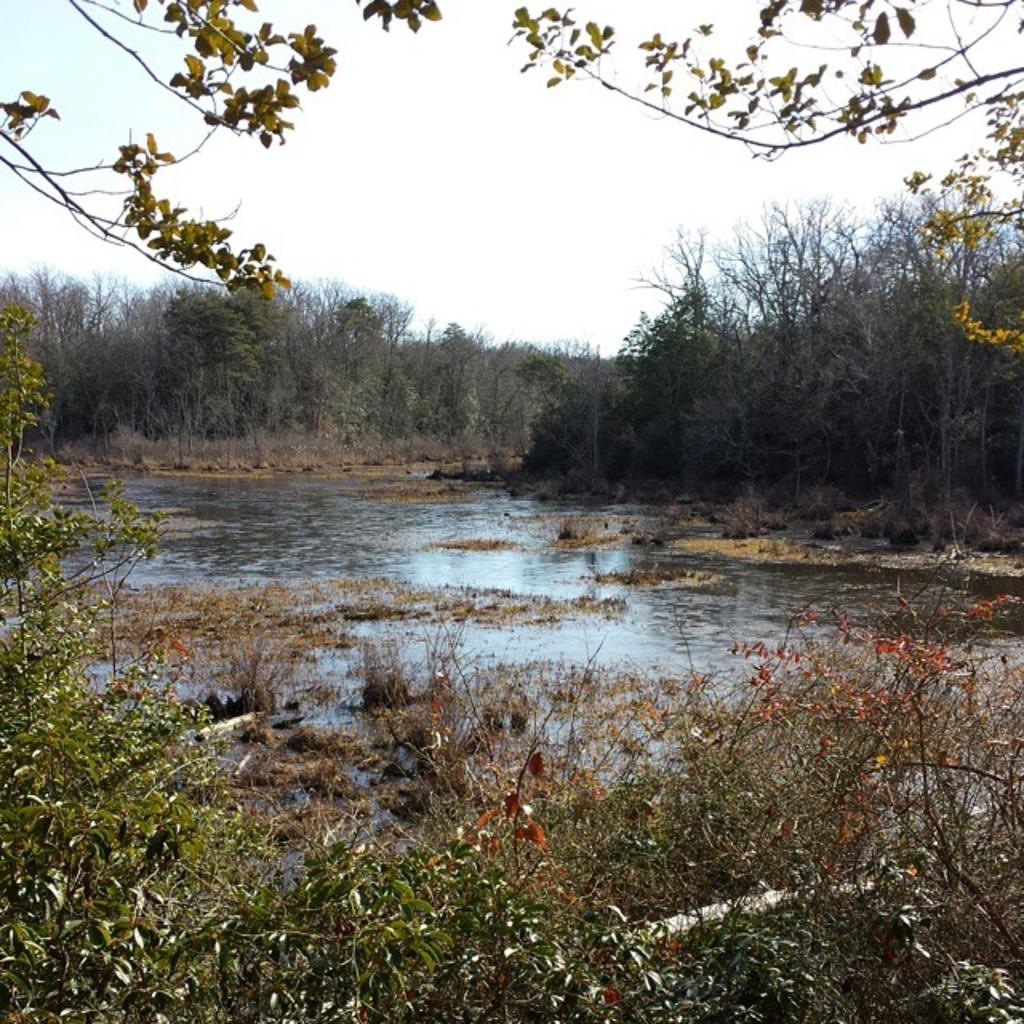What type of vegetation can be seen in the image? There are trees in the image. What natural element is visible in the image besides the trees? There is water visible in the image. What part of the natural environment is visible in the image? The sky is visible in the image. How many tails can be seen on the donkey in the image? There is no donkey present in the image, so it is not possible to determine the number of tails. 